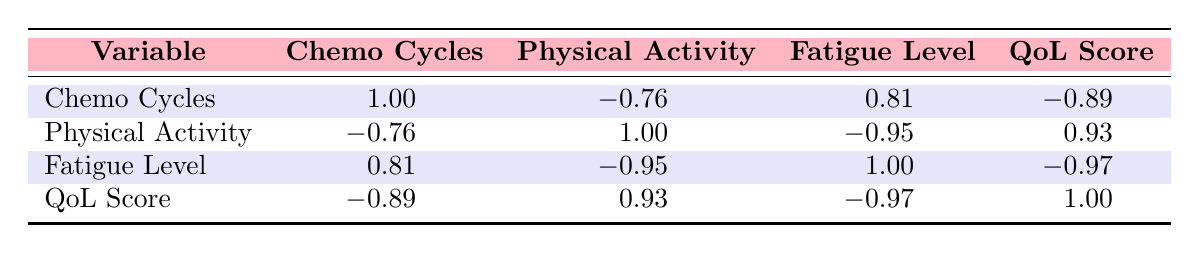What is the correlation between chemotherapy cycles and fatigue level? The table indicates a correlation of 0.81 between chemotherapy cycles and fatigue level. This means that as the number of chemotherapy cycles increases, the fatigue level tends to increase as well.
Answer: 0.81 Is there a negative correlation between physical activity and fatigue level? According to the table, the correlation between physical activity and fatigue level is -0.95. This suggests a strong negative relationship; as physical activity hours increase, fatigue levels tend to decrease.
Answer: Yes What is the Quality of Life score for the patient with the highest chemotherapy cycles? The patient with the highest number of chemotherapy cycles (8 cycles) has a Quality of Life score of 3. This information is derived from the first column of the table, identifying Patient ID 4 with the highest cycles.
Answer: 3 What is the average level of fatigue for patients with 6 or more chemotherapy cycles? The patients who have 6 or more chemotherapy cycles are Patient ID 1 (fatigue level 7), Patient ID 4 (fatigue level 9), and Patient ID 6 (fatigue level 8). To find the average, sum the fatigue levels (7 + 9 + 8 = 24) and divide by the number of patients (3), resulting in an average fatigue level of 24/3 = 8.
Answer: 8 Is the relationship between QoL score and physical activity positive? The table shows a correlation of 0.93 between QoL score and physical activity. This indicates a strong positive correlation; as physical activity increases, Quality of Life scores also tend to increase.
Answer: Yes How do fatigue levels compare between patients with 4 and 5 chemotherapy cycles? Patient ID 2 has 4 chemotherapy cycles and a fatigue level of 8, while Patient ID 3 has 5 cycles and a fatigue level of 6. Comparing the two, the patient with 5 cycles has a lower fatigue level, therefore experiencing less fatigue.
Answer: Patient with 5 cycles has lower fatigue 